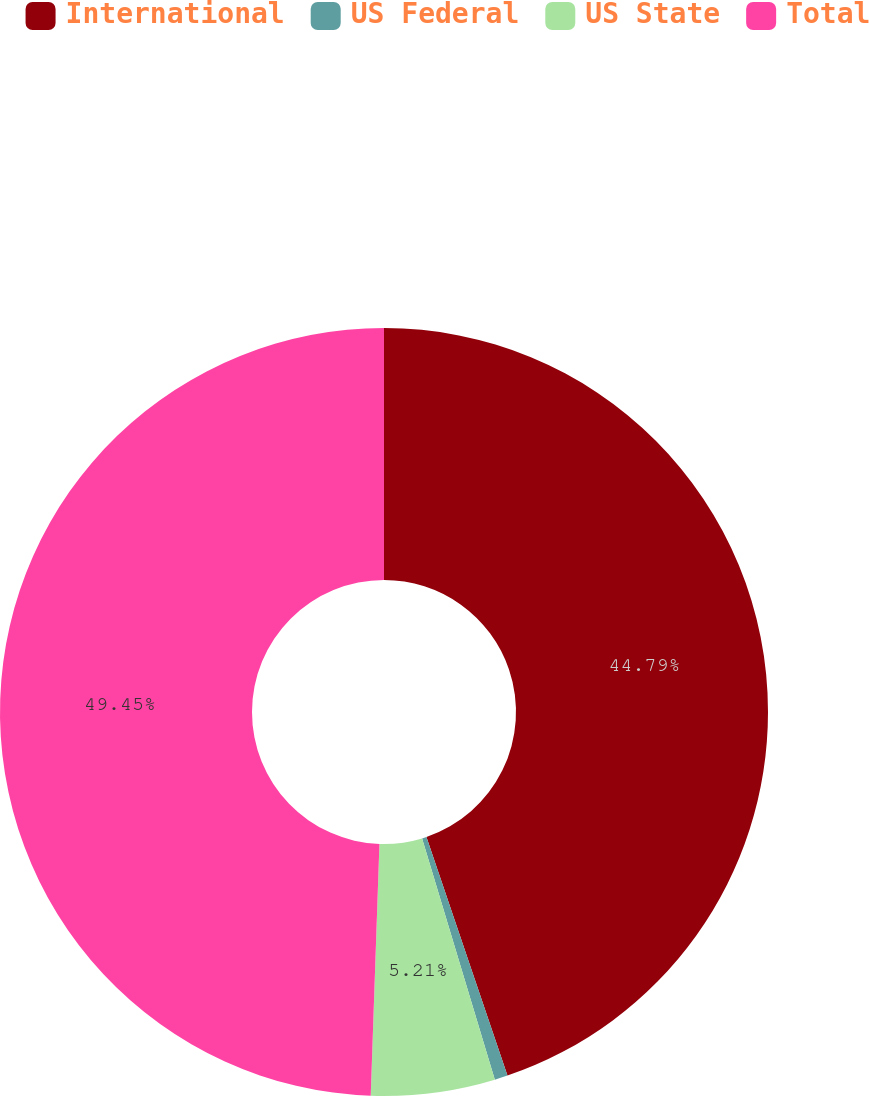<chart> <loc_0><loc_0><loc_500><loc_500><pie_chart><fcel>International<fcel>US Federal<fcel>US State<fcel>Total<nl><fcel>44.79%<fcel>0.55%<fcel>5.21%<fcel>49.45%<nl></chart> 